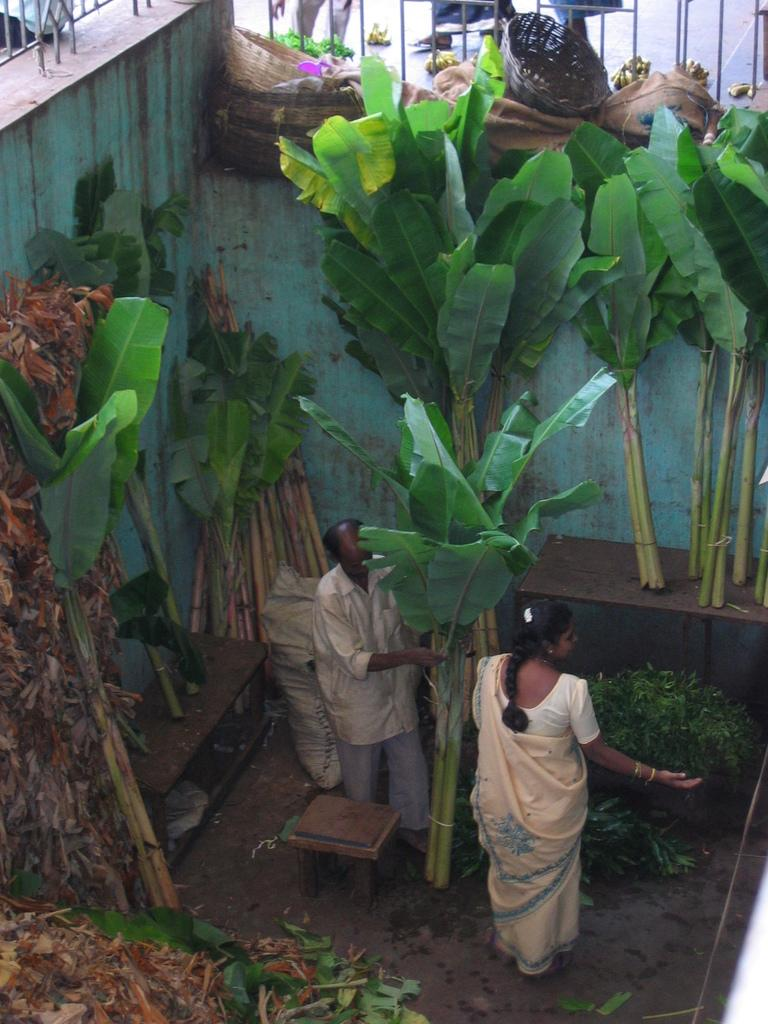How many people are in the image? There are two people in the image, a man and a woman. What are the man and woman holding in the image? The man and woman are holding banana trees in the image. What can be seen in the background of the image? There are walls visible in the image, and many banana trees are near the walls. What other items can be seen near the walls? There are various items near the walls in the image. How many frogs are sitting on the train in the image? There is no train or frogs present in the image. What achievement has the woman in the image recently accomplished? There is no information about any achievements in the image. 